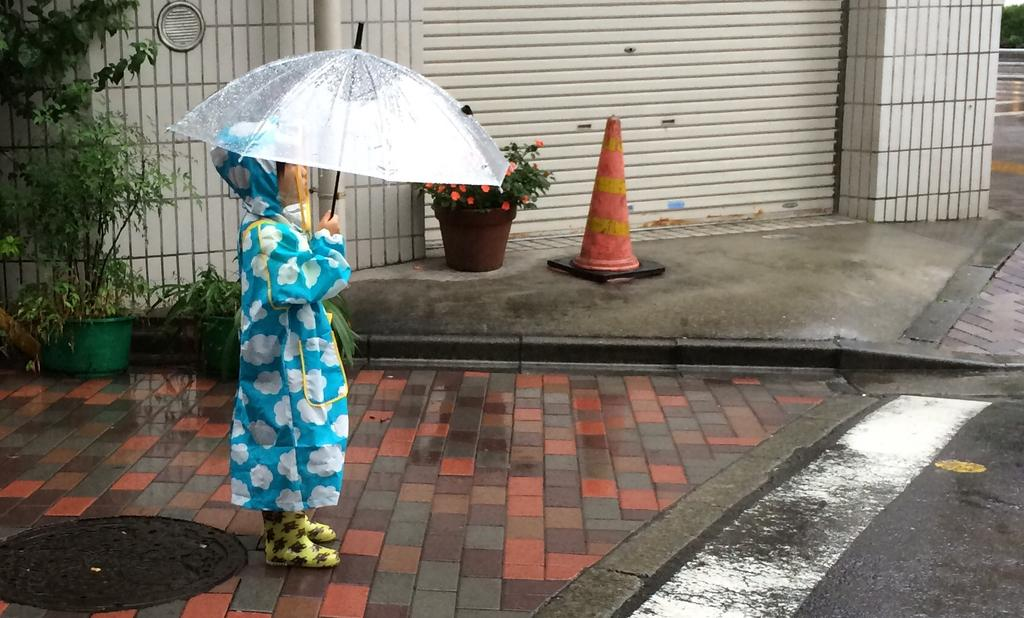What is located on the left side of the image? There is a child on the left side of the image. What is the child holding in the image? The child is holding an umbrella. What is the child's posture in the image? The child is standing in the image. What can be seen in the background of the image? There are pot plants, a shutter, and a road in the background of the image. What type of sand can be seen on the road in the image? There is no sand visible on the road in the image; it is a paved road. Are there any bears present in the image? No, there are no bears present in the image. 